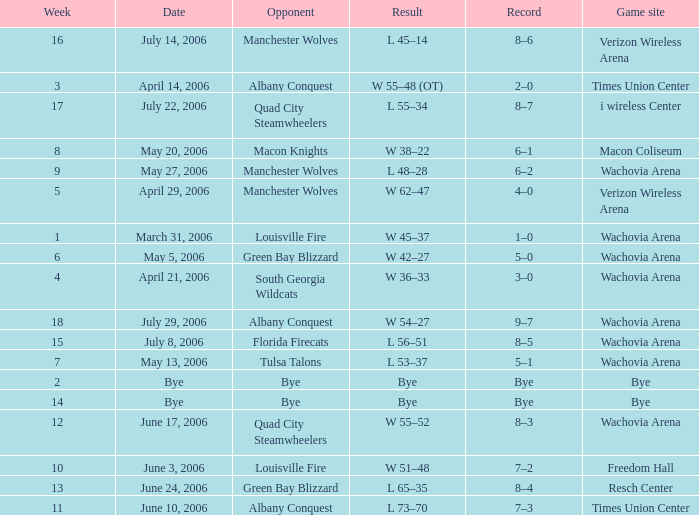What is the Game site week 1? Wachovia Arena. 